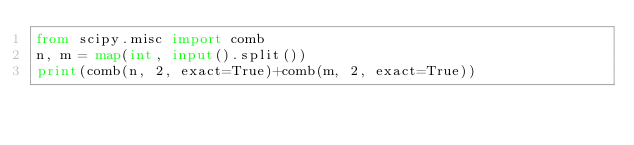Convert code to text. <code><loc_0><loc_0><loc_500><loc_500><_Python_>from scipy.misc import comb
n, m = map(int, input().split())
print(comb(n, 2, exact=True)+comb(m, 2, exact=True))</code> 